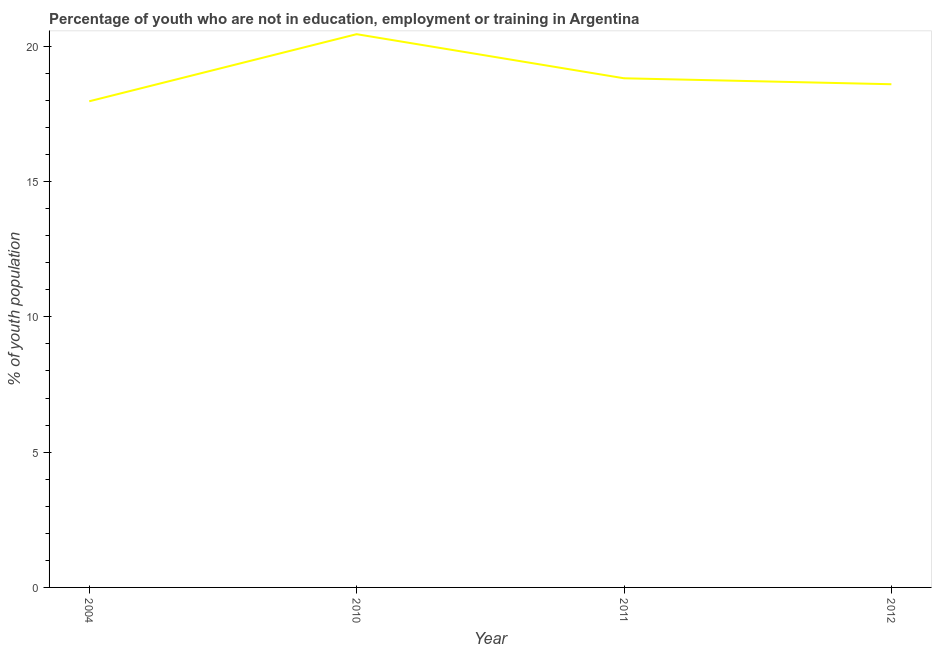What is the unemployed youth population in 2004?
Make the answer very short. 17.97. Across all years, what is the maximum unemployed youth population?
Provide a short and direct response. 20.45. Across all years, what is the minimum unemployed youth population?
Your answer should be compact. 17.97. In which year was the unemployed youth population minimum?
Your answer should be compact. 2004. What is the sum of the unemployed youth population?
Your answer should be compact. 75.84. What is the difference between the unemployed youth population in 2004 and 2011?
Ensure brevity in your answer.  -0.85. What is the average unemployed youth population per year?
Your answer should be compact. 18.96. What is the median unemployed youth population?
Offer a very short reply. 18.71. Do a majority of the years between 2010 and 2004 (inclusive) have unemployed youth population greater than 15 %?
Ensure brevity in your answer.  No. What is the ratio of the unemployed youth population in 2011 to that in 2012?
Offer a terse response. 1.01. Is the unemployed youth population in 2004 less than that in 2011?
Your answer should be very brief. Yes. Is the difference between the unemployed youth population in 2010 and 2011 greater than the difference between any two years?
Give a very brief answer. No. What is the difference between the highest and the second highest unemployed youth population?
Ensure brevity in your answer.  1.63. What is the difference between the highest and the lowest unemployed youth population?
Offer a very short reply. 2.48. In how many years, is the unemployed youth population greater than the average unemployed youth population taken over all years?
Provide a succinct answer. 1. Does the unemployed youth population monotonically increase over the years?
Your response must be concise. No. Are the values on the major ticks of Y-axis written in scientific E-notation?
Your response must be concise. No. What is the title of the graph?
Offer a very short reply. Percentage of youth who are not in education, employment or training in Argentina. What is the label or title of the Y-axis?
Your response must be concise. % of youth population. What is the % of youth population of 2004?
Keep it short and to the point. 17.97. What is the % of youth population of 2010?
Provide a succinct answer. 20.45. What is the % of youth population in 2011?
Your response must be concise. 18.82. What is the % of youth population in 2012?
Ensure brevity in your answer.  18.6. What is the difference between the % of youth population in 2004 and 2010?
Provide a succinct answer. -2.48. What is the difference between the % of youth population in 2004 and 2011?
Make the answer very short. -0.85. What is the difference between the % of youth population in 2004 and 2012?
Your response must be concise. -0.63. What is the difference between the % of youth population in 2010 and 2011?
Your answer should be compact. 1.63. What is the difference between the % of youth population in 2010 and 2012?
Your answer should be compact. 1.85. What is the difference between the % of youth population in 2011 and 2012?
Provide a short and direct response. 0.22. What is the ratio of the % of youth population in 2004 to that in 2010?
Your response must be concise. 0.88. What is the ratio of the % of youth population in 2004 to that in 2011?
Provide a succinct answer. 0.95. What is the ratio of the % of youth population in 2004 to that in 2012?
Offer a terse response. 0.97. What is the ratio of the % of youth population in 2010 to that in 2011?
Provide a short and direct response. 1.09. What is the ratio of the % of youth population in 2010 to that in 2012?
Offer a terse response. 1.1. 